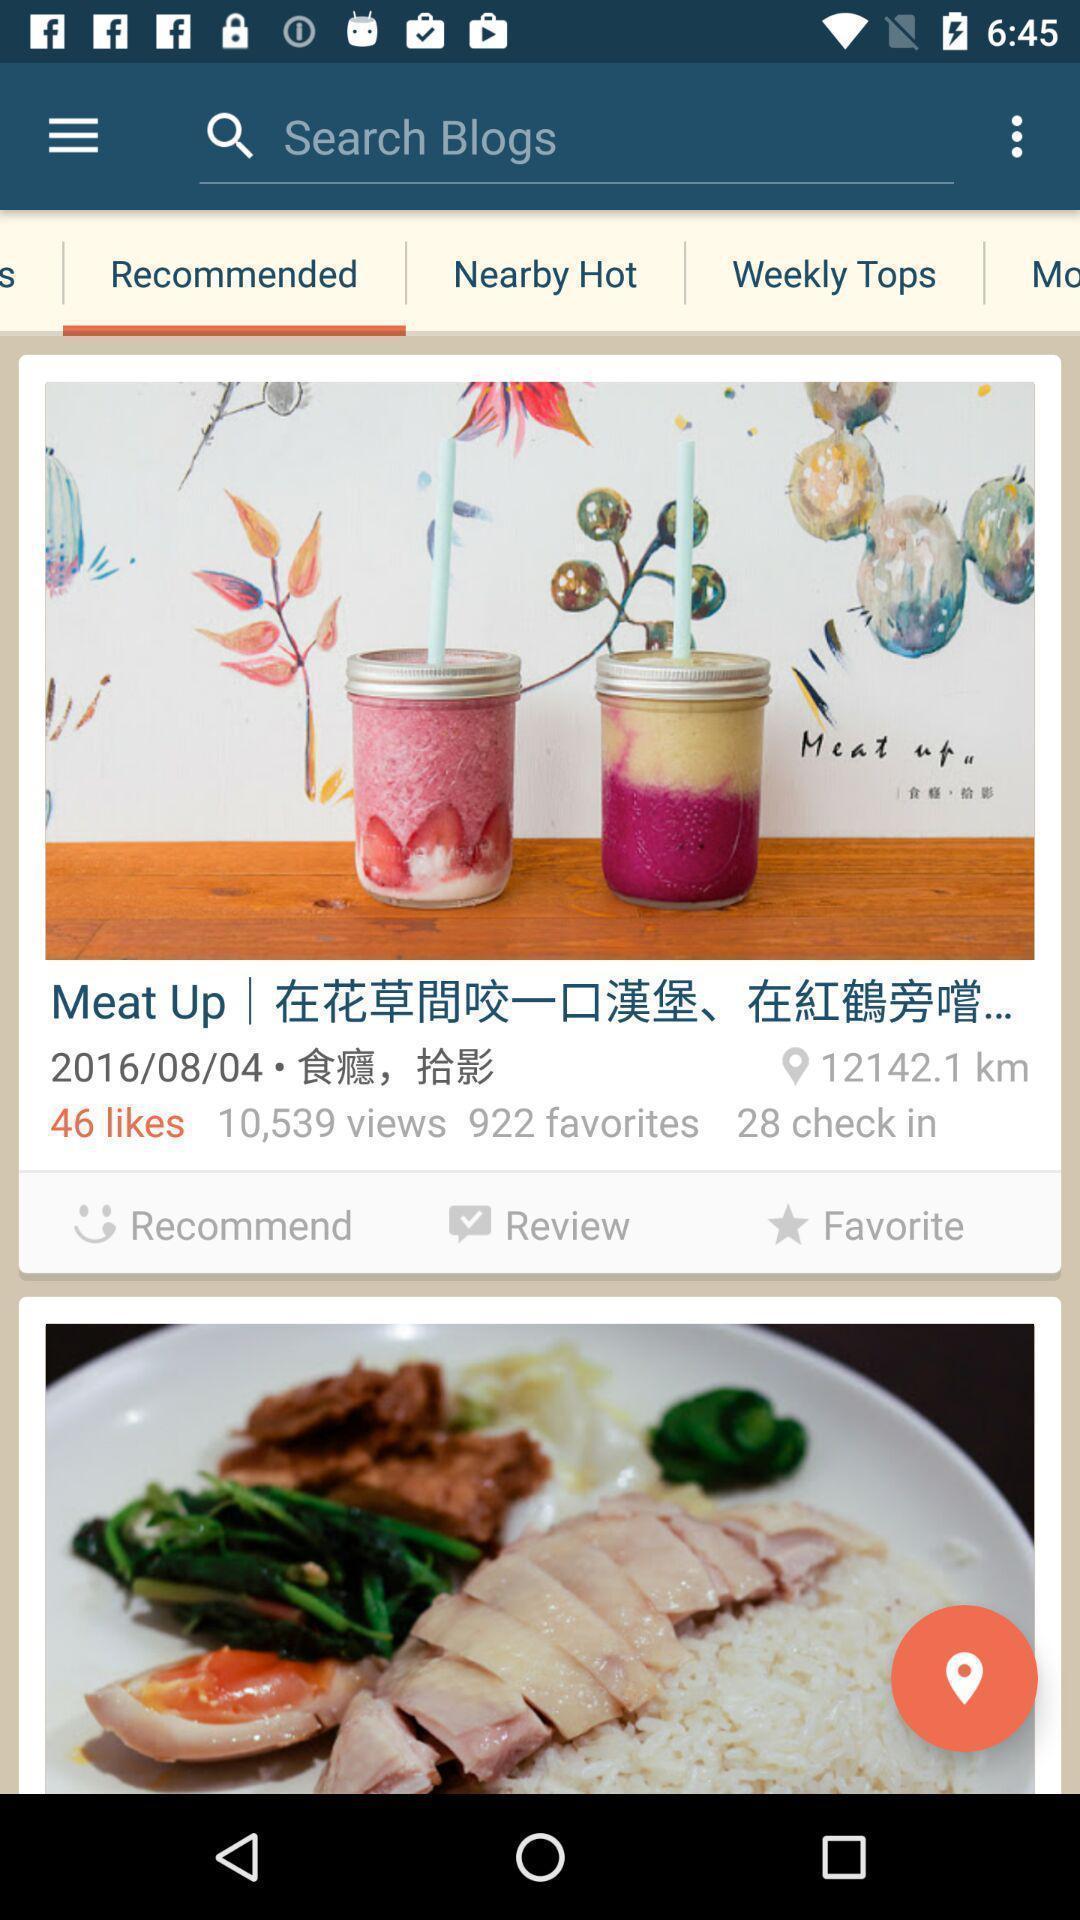Provide a description of this screenshot. Search page in a blogging app. 